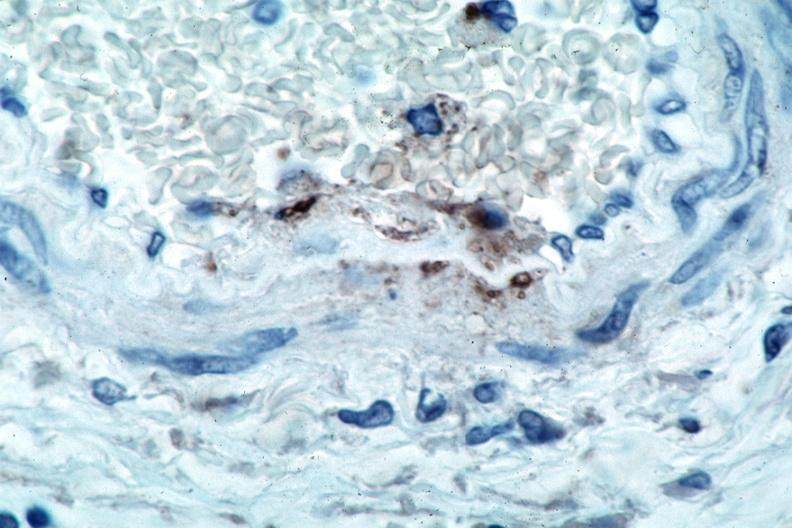s sacrococcygeal teratoma present?
Answer the question using a single word or phrase. No 